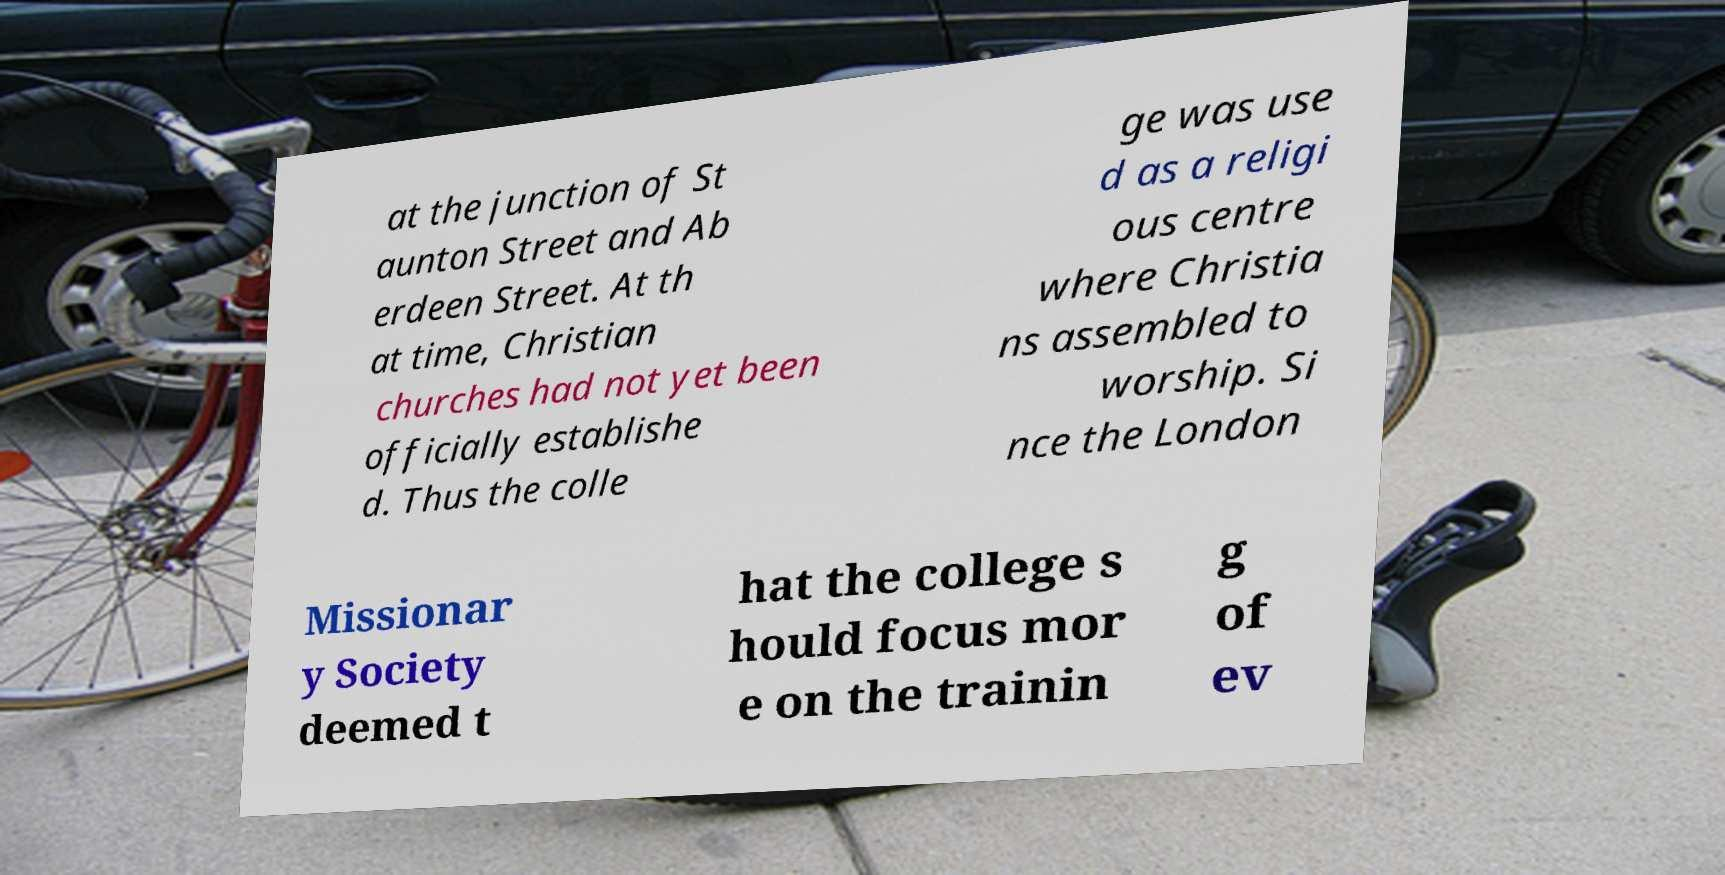Can you accurately transcribe the text from the provided image for me? at the junction of St aunton Street and Ab erdeen Street. At th at time, Christian churches had not yet been officially establishe d. Thus the colle ge was use d as a religi ous centre where Christia ns assembled to worship. Si nce the London Missionar y Society deemed t hat the college s hould focus mor e on the trainin g of ev 